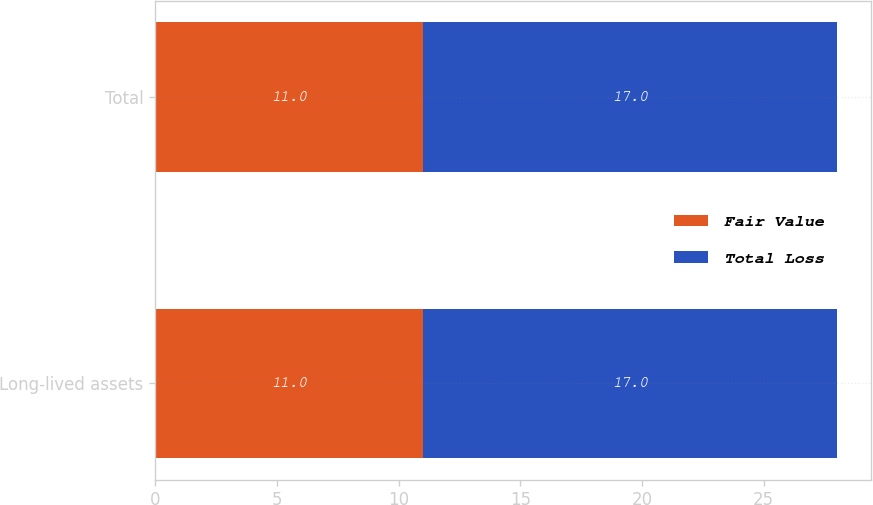Convert chart. <chart><loc_0><loc_0><loc_500><loc_500><stacked_bar_chart><ecel><fcel>Long-lived assets<fcel>Total<nl><fcel>Fair Value<fcel>11<fcel>11<nl><fcel>Total Loss<fcel>17<fcel>17<nl></chart> 